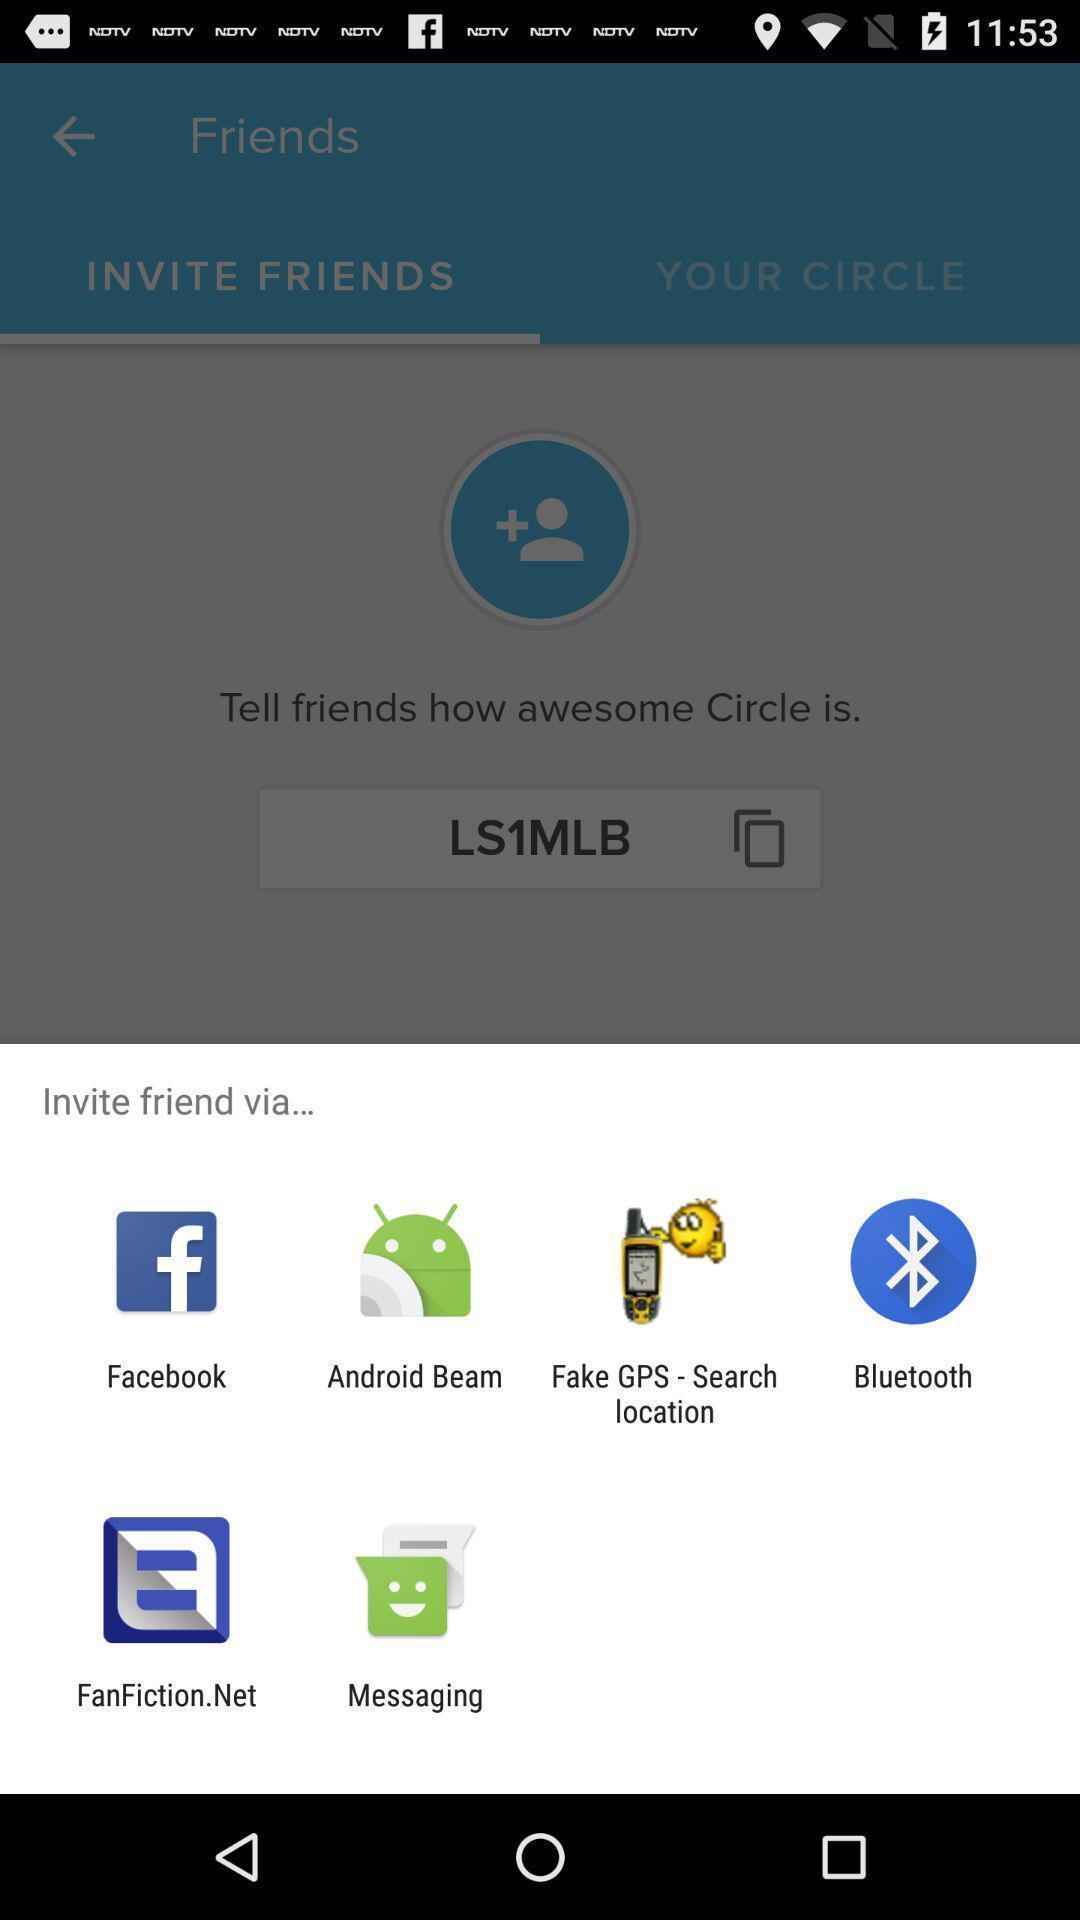Provide a detailed account of this screenshot. Popup showing some options with icons. 